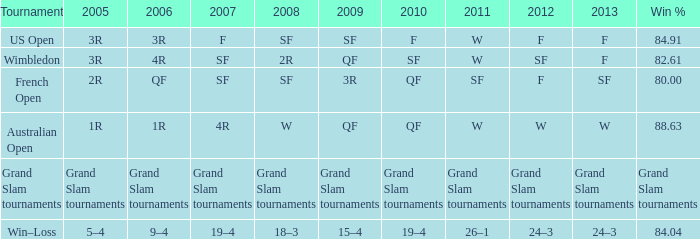What in 2007 contains a 2008 of sf, and a 2010 of f? F. 